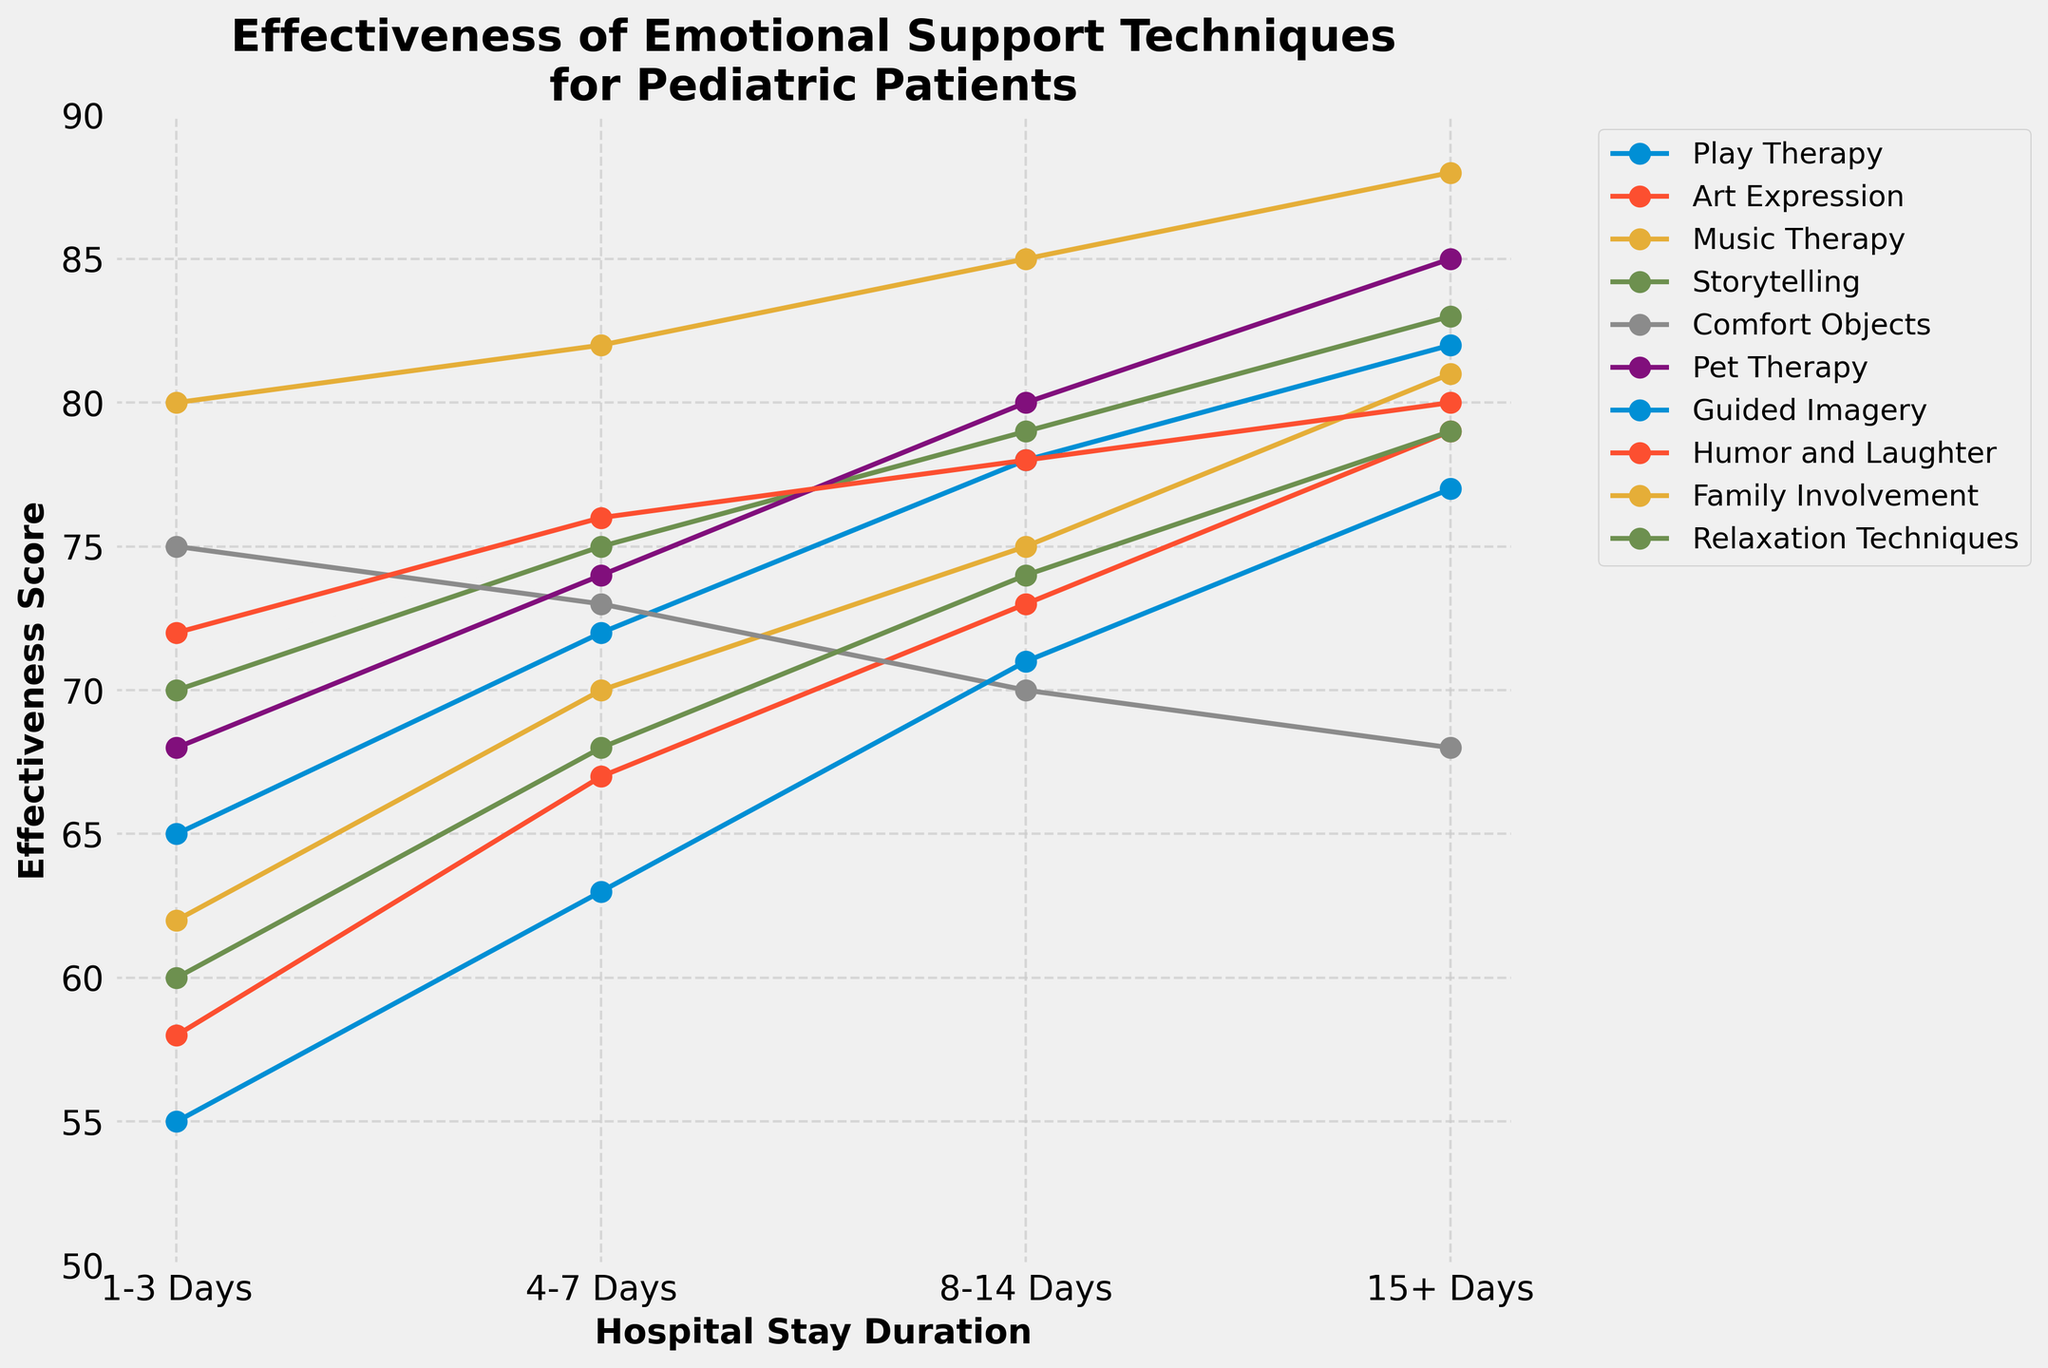Which technique shows the highest effectiveness score for the 15+ Days hospital stay duration? Reviewing the plot, Family Involvement shows the highest effectiveness score in the 15+ Days duration.
Answer: Family Involvement How does the effectiveness of Comfort Objects change as the hospital stay duration increases? Tracking the Comfort Objects line, its effectiveness decreases as the hospital stay duration increases.
Answer: Decreases Among play therapy and art expression, which one has a higher effectiveness score for the 4-7 Days duration? Examining the plot, Play Therapy has an effectiveness score of 72, while Art Expression has 67.
Answer: Play Therapy What is the average effectiveness score of Music Therapy across all the durations? Music Therapy has effectiveness scores of 62, 70, 75, and 81. The average is (62 + 70 + 75 + 81) / 4 = 72.
Answer: 72 Which technique has a decreasing effectiveness trend over increasing hospital stay durations? Comfort Objects is the only technique that decreases in effectiveness across increasing durations.
Answer: Comfort Objects Comparing the effectiveness of Pet Therapy and Storytelling for 1-3 Days and 15+ Days, which technique shows a more significant increase? Pet Therapy increases from 68 to 85 (17 points), while Storytelling increases from 70 to 83 (13 points).
Answer: Pet Therapy For the 8-14 Days duration, which technique is the least effective? Guided Imagery has the lowest effectiveness score at 71 for this duration.
Answer: Guided Imagery How does the effectiveness of Humor and Laughter change from 1-3 Days to 15+ Days? The effectiveness of Humor and Laughter changes from 72 to 80, increasing by 8 points.
Answer: Increases by 8 points Identify the technique with the most significant difference in effectiveness between 4-7 Days and 8-14 Days. Pet Therapy increases from 74 to 80, resulting in a 6-point difference, which is the largest among the techniques.
Answer: Pet Therapy 